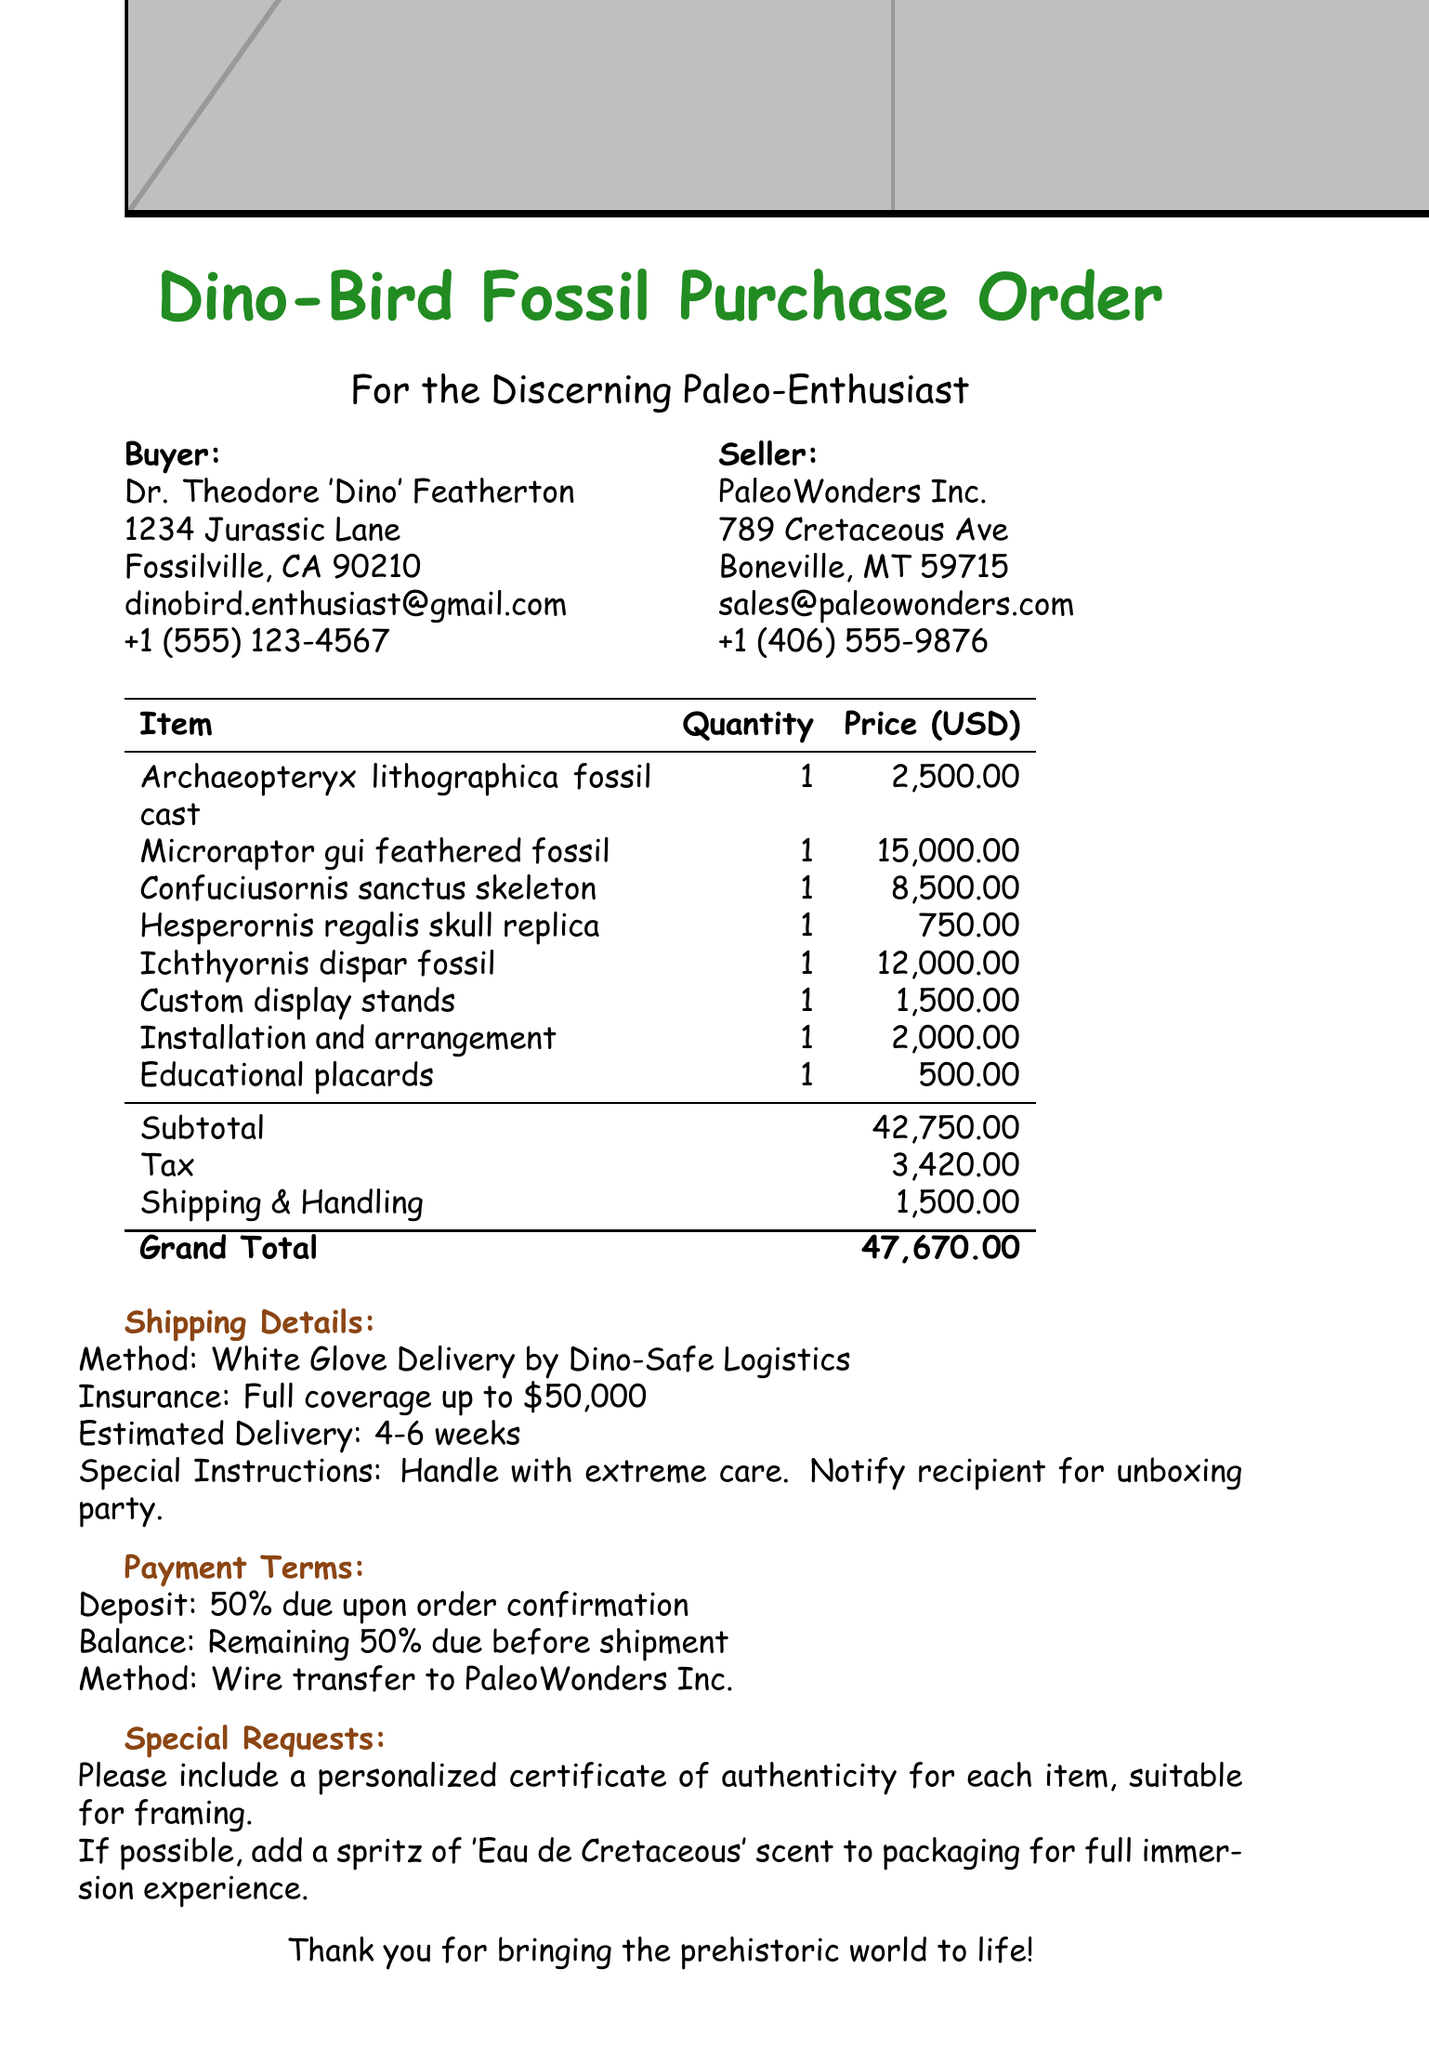What is the name of the buyer? The buyer's name is explicitly stated at the beginning of the document.
Answer: Dr. Theodore 'Dino' Featherton How many items are listed in the order details? The order details section lists the items in a table format. Counting the rows reveals the total.
Answer: 5 What is the unit price of the Microraptor gui feathered fossil? The unit price is indicated next to the respective item in the order details table.
Answer: 15000.00 What is the total before tax? The total before tax is stated clearly in the document as the sum of the items before tax.
Answer: 42750.00 What delivery method is used for shipping? The method is specified in the shipping details section of the document.
Answer: White Glove Delivery by Dino-Safe Logistics What is the balance payment due before shipment? The payment terms outline the balance due, which is the remaining amount after the deposit.
Answer: 50 % How much will the installation and arrangement service cost? The cost for this additional service is listed in the additional services section.
Answer: 2000.00 What is the estimated delivery time? The estimated delivery time is provided in the shipping details section.
Answer: 4-6 weeks What special request is noted regarding the packaging? The special requests are included in the designated section which outlines specific preferences for the order.
Answer: Eau de Cretaceous scent 